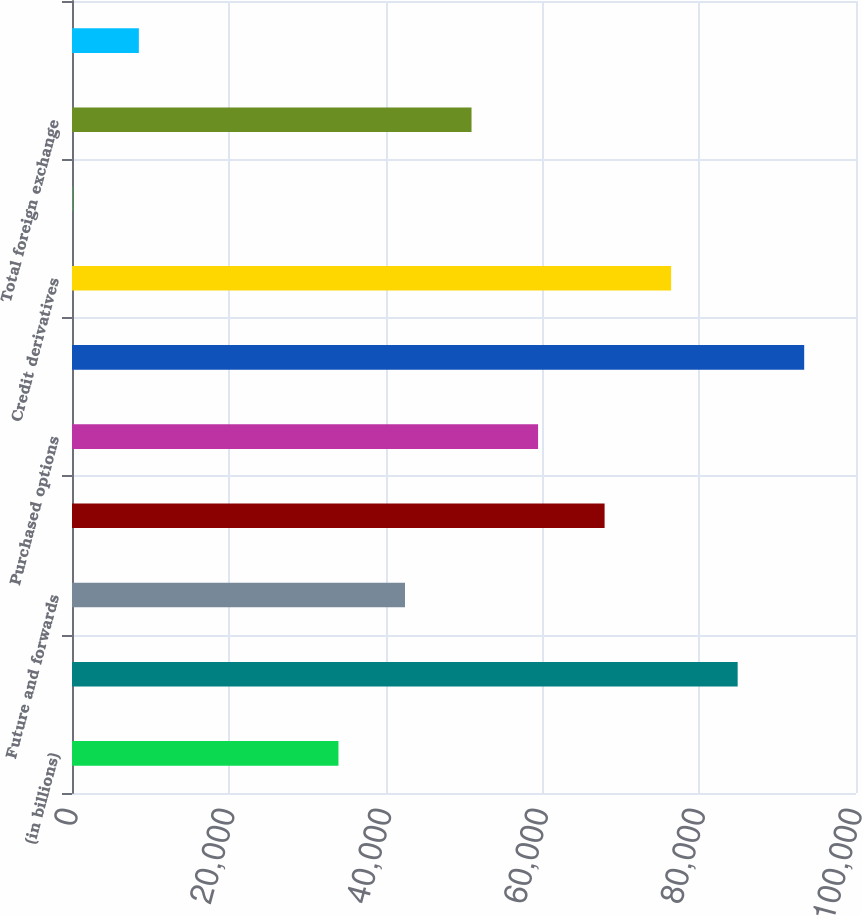<chart> <loc_0><loc_0><loc_500><loc_500><bar_chart><fcel>(in billions)<fcel>Interest rate and currency<fcel>Future and forwards<fcel>Written options (c)<fcel>Purchased options<fcel>Total interest rate contracts<fcel>Credit derivatives<fcel>Foreign exchange spot<fcel>Total foreign exchange<fcel>Swaps<nl><fcel>33986.8<fcel>84907<fcel>42473.5<fcel>67933.6<fcel>59446.9<fcel>93393.7<fcel>76420.3<fcel>40<fcel>50960.2<fcel>8526.7<nl></chart> 